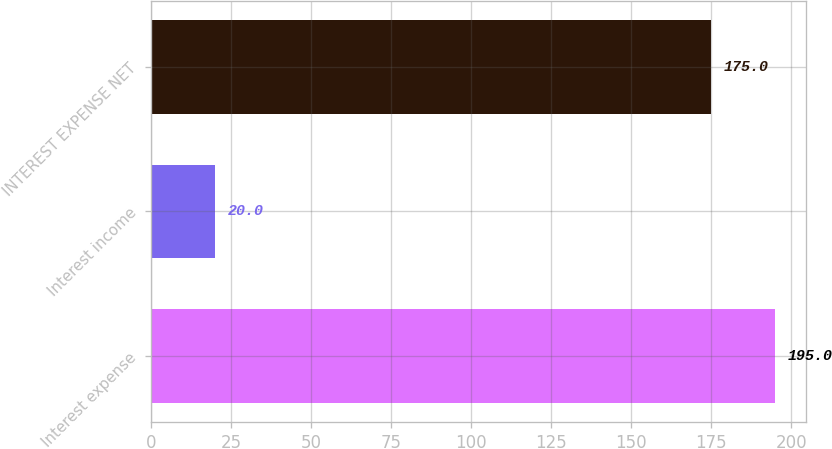<chart> <loc_0><loc_0><loc_500><loc_500><bar_chart><fcel>Interest expense<fcel>Interest income<fcel>INTEREST EXPENSE NET<nl><fcel>195<fcel>20<fcel>175<nl></chart> 